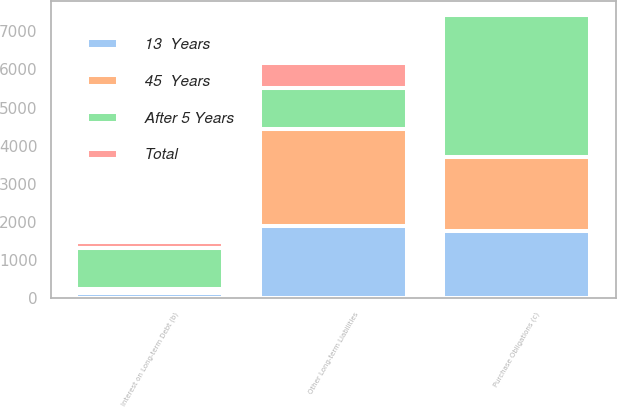Convert chart to OTSL. <chart><loc_0><loc_0><loc_500><loc_500><stacked_bar_chart><ecel><fcel>Interest on Long-term Debt (b)<fcel>Purchase Obligations (c)<fcel>Other Long-term Liabilities<nl><fcel>After 5 Years<fcel>1067<fcel>3712<fcel>1067<nl><fcel>45  Years<fcel>108<fcel>1953<fcel>2547<nl><fcel>13  Years<fcel>148<fcel>1752<fcel>1900<nl><fcel>Total<fcel>143<fcel>5<fcel>648<nl></chart> 